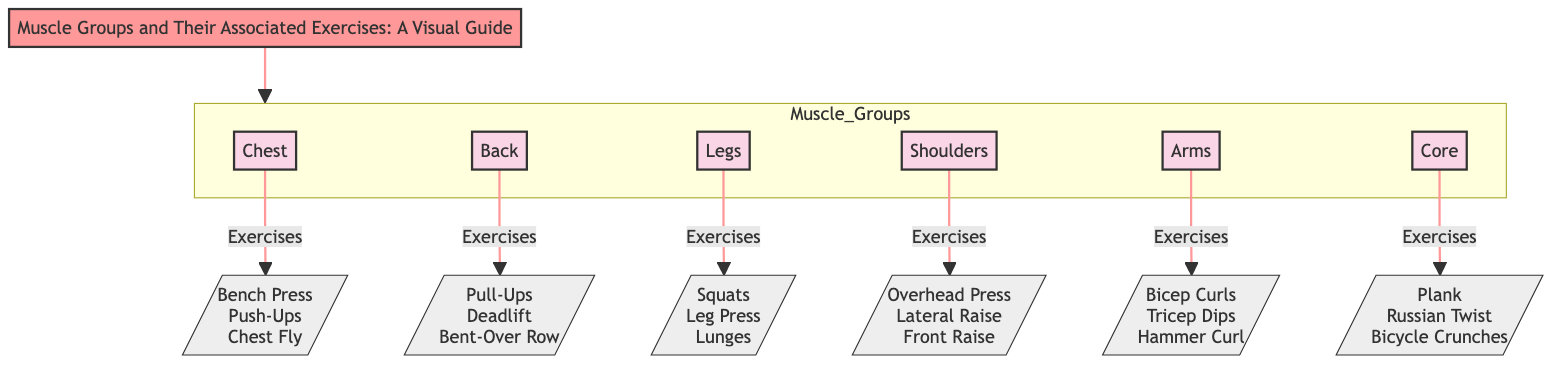What are the primary muscle groups depicted in the diagram? The diagram features six main nodes representing muscle groups: Chest, Back, Legs, Shoulders, Arms, and Core.
Answer: Chest, Back, Legs, Shoulders, Arms, Core Which exercise is associated with the Core muscle group? The Core muscle group connects to three exercises listed in the diagram: Plank, Russian Twist, and Bicycle Crunches. Among these, any can be named as an answer, but attention to the question suggests a single name may suffice.
Answer: Plank How many exercises are listed for the Arms muscle group? The Arms muscle group is connected to three specific exercises: Bicep Curls, Tricep Dips, and Hammer Curl. Thus, counting these provides the answer.
Answer: 3 What links the Back muscle group to its exercises? The Back muscle group is directly connected by the phrase "Exercises" to its listed exercises, which are Pull-Ups, Deadlift, and Bent-Over Row. The relationship can be clearly identified as an arrow leading from Back to the exercises.
Answer: Exercises Are there more exercises listed for Legs than for Shoulders? The Legs muscle group is associated with three exercises: Squats, Leg Press, and Lunges. In contrast, Shoulders is associated with only three exercises: Overhead Press, Lateral Raise, and Front Raise. Since both have the same number, they aren’t unequal; this requires a comparison of number counts.
Answer: No Which muscle group has exercises that include the term "Press"? The Chest muscle group contains exercises that include "Bench Press," while the Shoulders group includes "Overhead Press." Both exercise categories involve "Press." Thus, it can be narrowed down to identifying them within the respective muscle groups.
Answer: Chest, Shoulders What is the title of the diagram? The title, prominently displayed in the diagram, is "Muscle Groups and Their Associated Exercises: A Visual Guide." This direct identification provides the title effectively.
Answer: Muscle Groups and Their Associated Exercises: A Visual Guide How many total muscle groups are illustrated in the diagram? A total of six muscle groups are illustrated: Chest, Back, Legs, Shoulders, Arms, and Core. The counting of each distinct muscle group node results in the total.
Answer: 6 